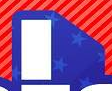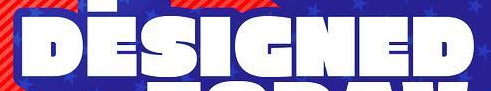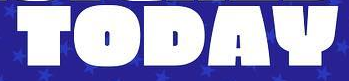What text is displayed in these images sequentially, separated by a semicolon? I; DESIGNED; TODAY 